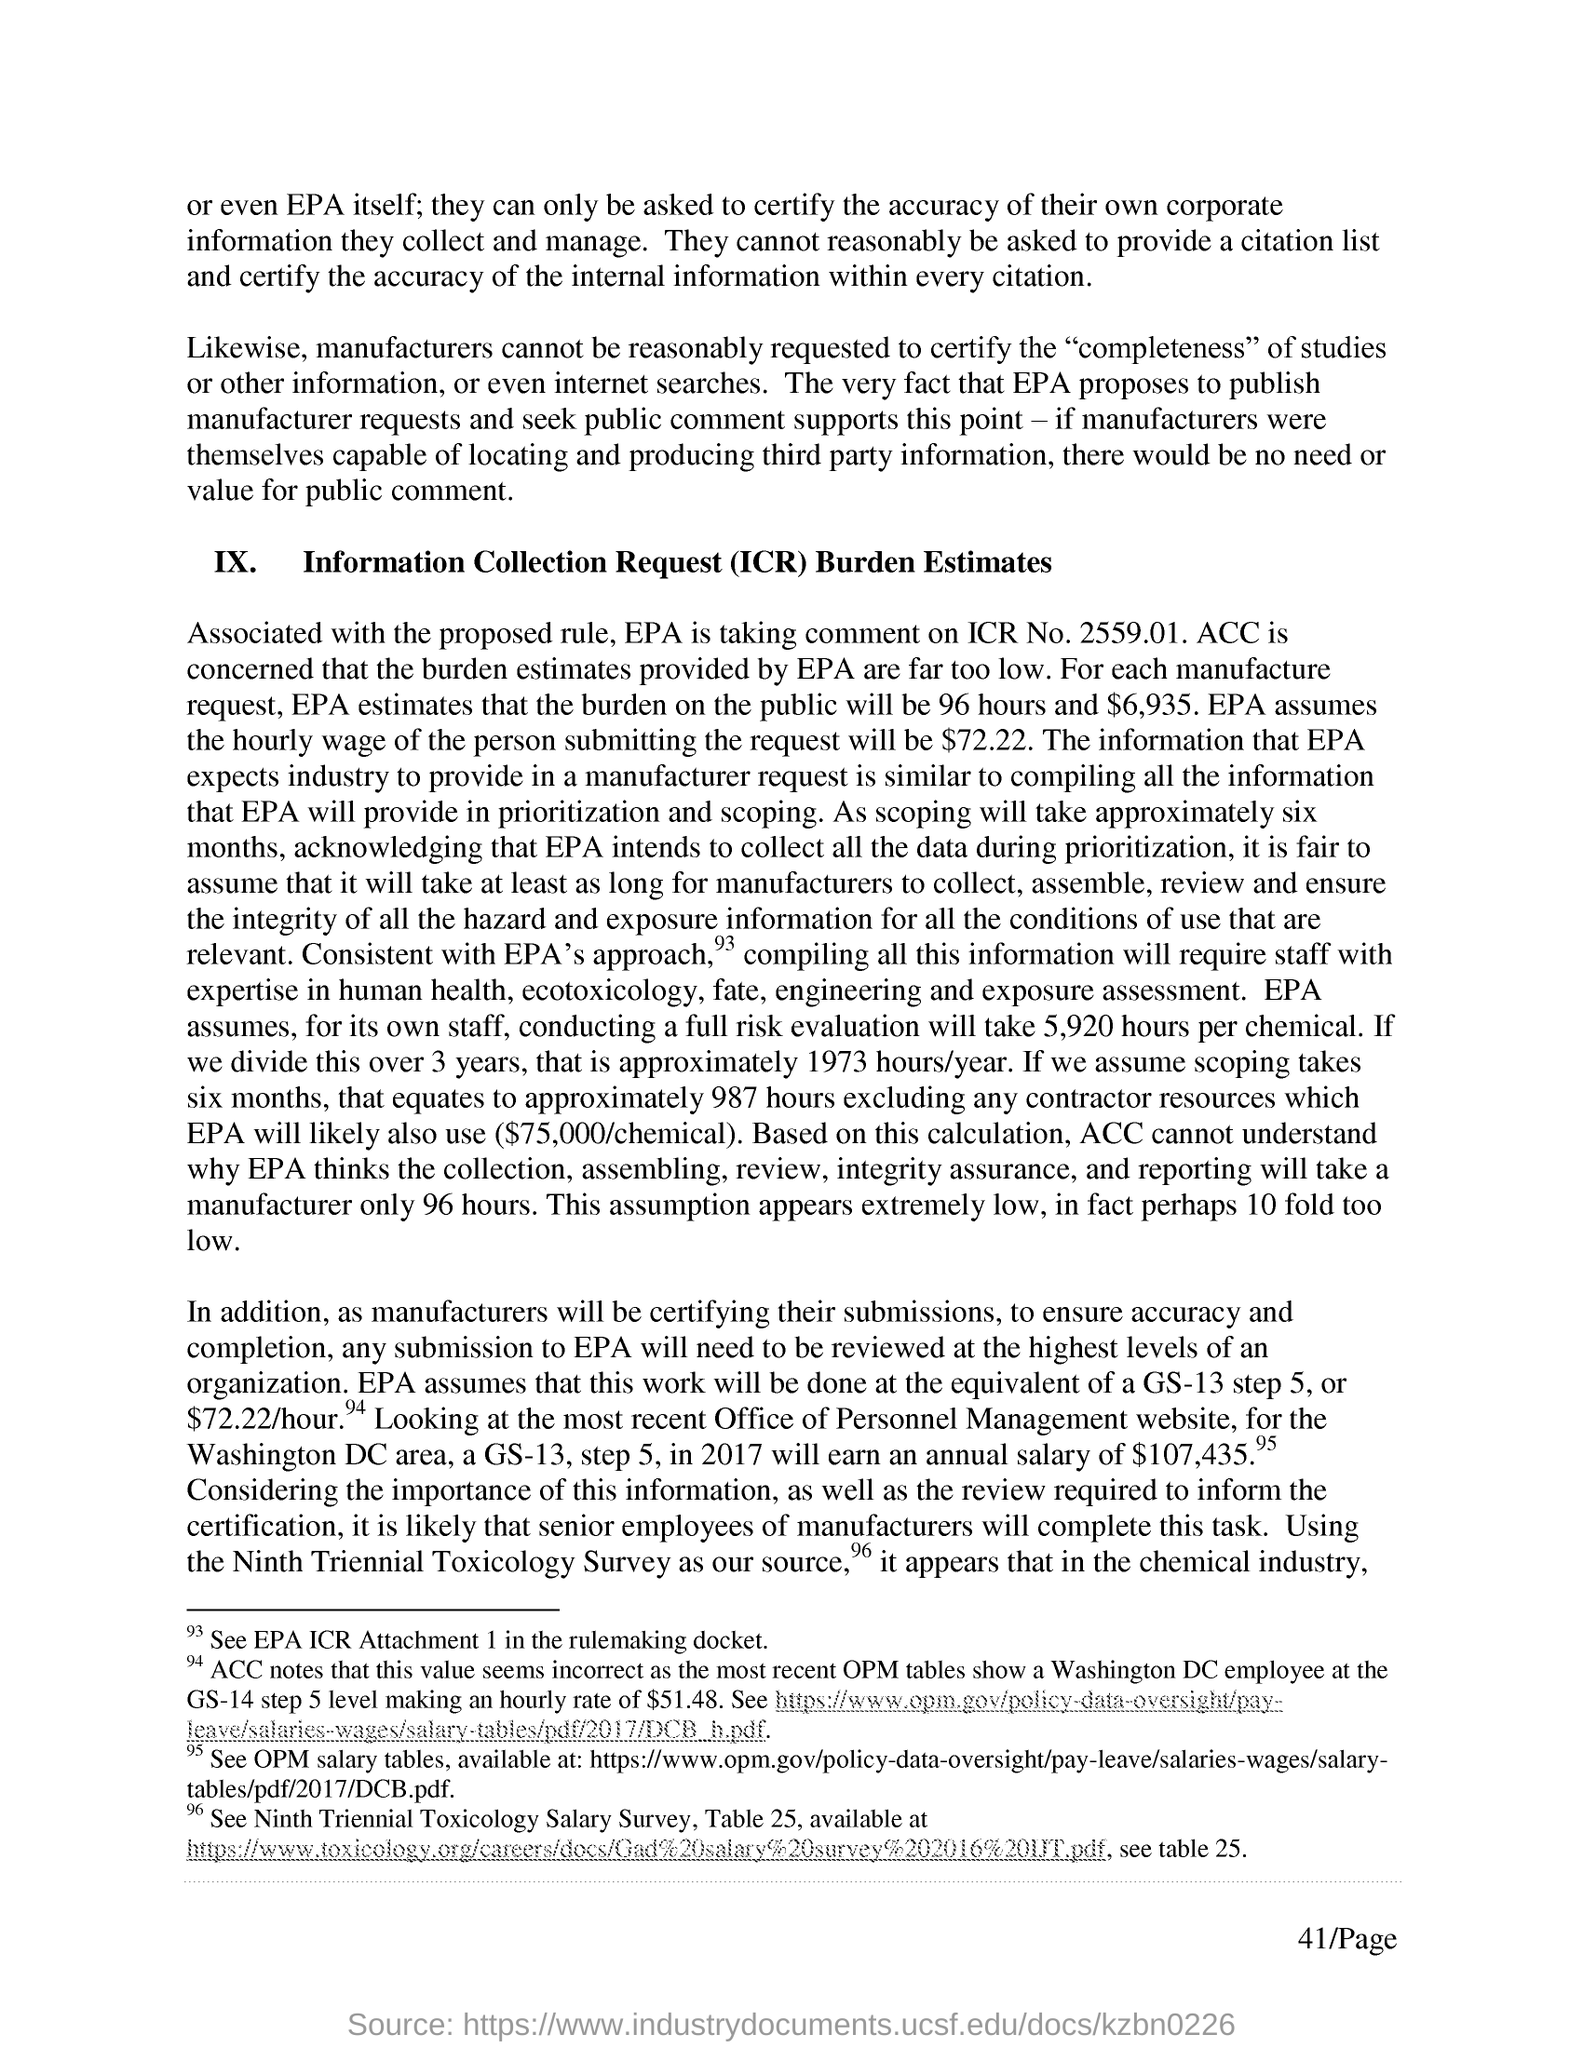ICR Stands for ?
Offer a terse response. Information collection request. EPA is taking comment on ICR No ?
Ensure brevity in your answer.  2559.01. For each manufacture request , epa estimates that the burden on public will be how many hours ?
Give a very brief answer. 96 hours. 